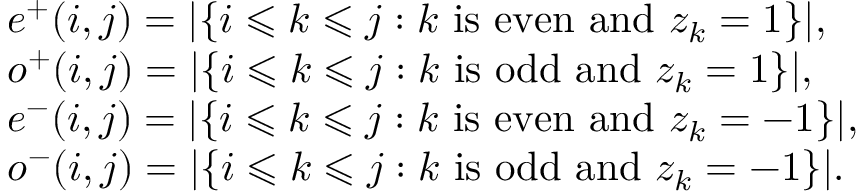Convert formula to latex. <formula><loc_0><loc_0><loc_500><loc_500>\begin{array} { r l } & { e ^ { + } ( i , j ) = | \{ i \leqslant k \leqslant j \colon k i s e v e n a n d z _ { k } = 1 \} | , } \\ & { o ^ { + } ( i , j ) = | \{ i \leqslant k \leqslant j \colon k i s o d d a n d z _ { k } = 1 \} | , } \\ & { e ^ { - } ( i , j ) = | \{ i \leqslant k \leqslant j \colon k i s e v e n a n d z _ { k } = - 1 \} | , } \\ & { o ^ { - } ( i , j ) = | \{ i \leqslant k \leqslant j \colon k i s o d d a n d z _ { k } = - 1 \} | . } \end{array}</formula> 